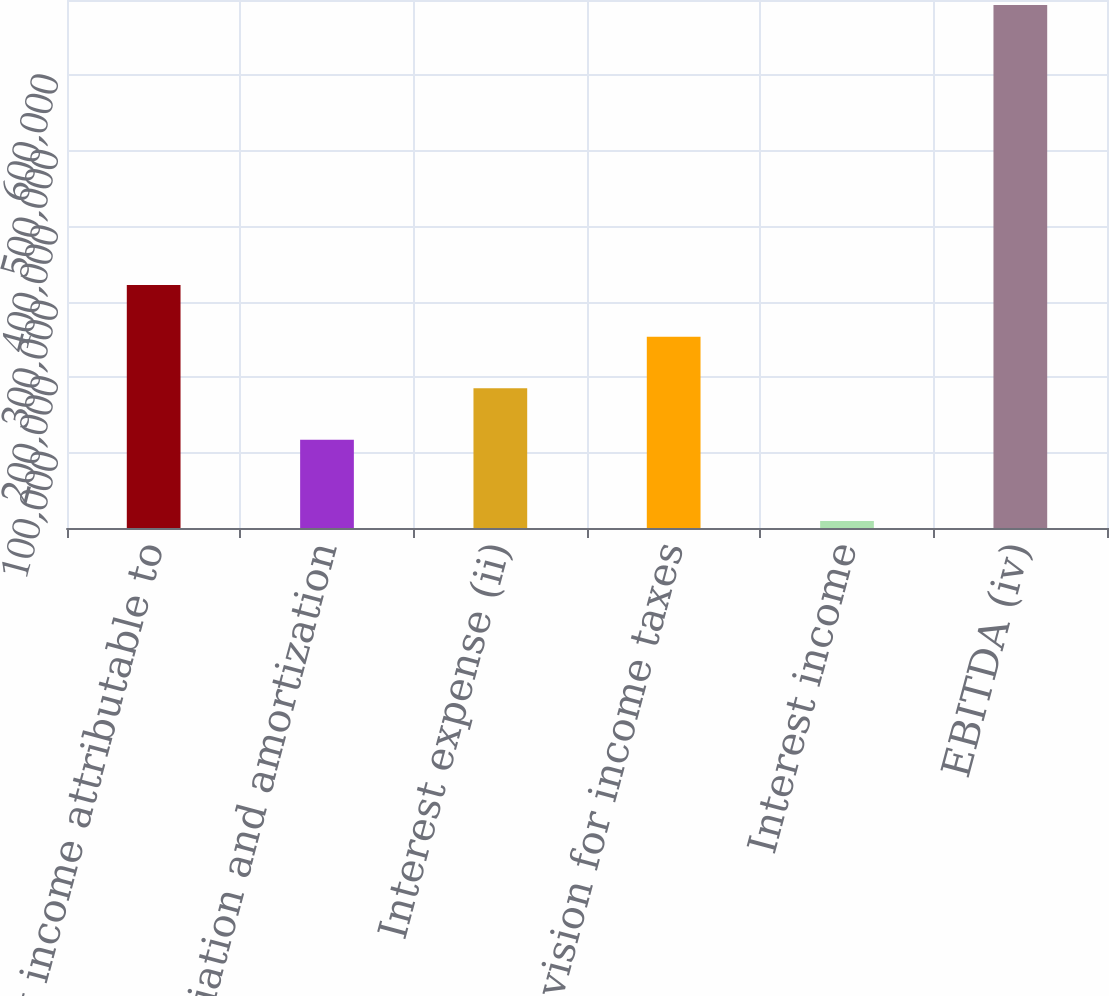<chart> <loc_0><loc_0><loc_500><loc_500><bar_chart><fcel>Net income attributable to<fcel>Depreciation and amortization<fcel>Interest expense (ii)<fcel>Provision for income taxes<fcel>Interest income<fcel>EBITDA (iv)<nl><fcel>322075<fcel>116930<fcel>185312<fcel>253694<fcel>9443<fcel>693261<nl></chart> 